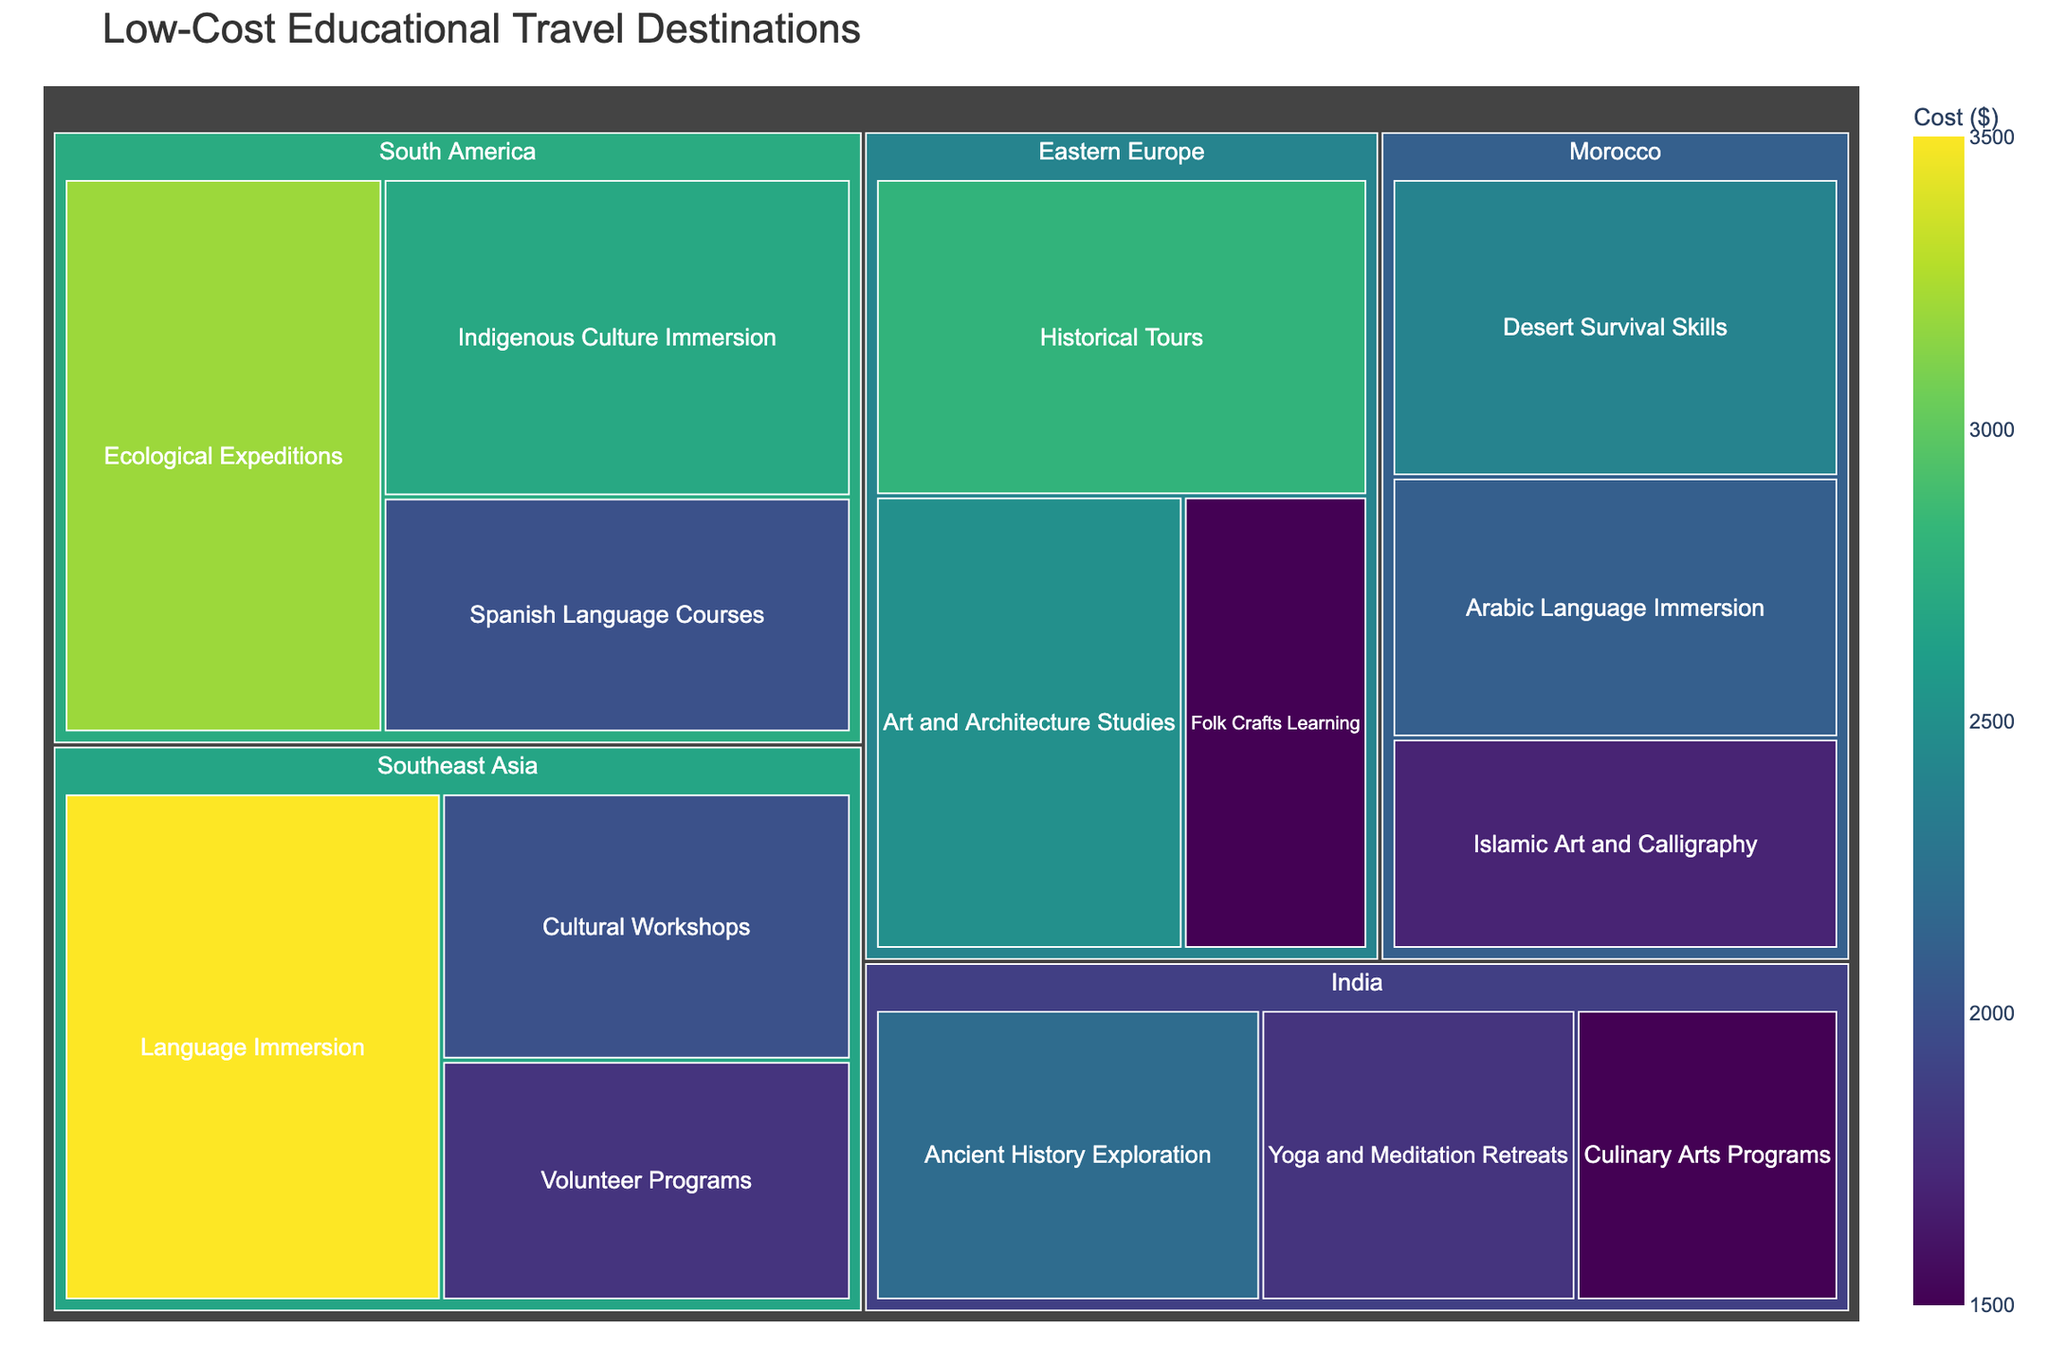What's the title of the treemap? The title is usually displayed at the top of the treemap. It is meant to summarize the overall content of the visualization.
Answer: Low-Cost Educational Travel Destinations How many regions are represented in the treemap? By examining the top-level categories in the treemap, you can count the distinct regions.
Answer: 5 What is the cost of attending Yoga and Meditation Retreats in India? Locate the "India" region and then find the "Yoga and Meditation Retreats" category within it. The cost is displayed within that segment.
Answer: $1800 Which region has the least expensive learning opportunity, and what is the opportunity? Identify the smallest rectangle with the lowest cost value displayed. Cross-check which region it belongs to.
Answer: Eastern Europe, Folk Crafts Learning Compare the costs of Language Immersion programs in Southeast Asia and Arabic Language Immersion in Morocco. Which one is cheaper? Locate both categories in their respective regions and compare their cost values directly.
Answer: Arabic Language Immersion in Morocco What is the total cost of all learning opportunities in South America? Sum the costs of all the segments within the South America region. Individual costs are $3200, $2700, and $2000 respectively. So, 3200 + 2700 + 2000 = 7900.
Answer: $7900 Which learning opportunity has the highest cost, and how much does it cost? Find the segment with the highest value. Look across all regions to identify this.
Answer: Language Immersion in Southeast Asia, $3500 How many different types of learning opportunities are offered in Eastern Europe? Count the number of distinct segments within the Eastern Europe region.
Answer: 3 What's the cost difference between Ecological Expeditions in South America and Desert Survival Skills in Morocco? Find the cost of each learning opportunity and subtract the lower cost from the higher cost. $3200 - $2400 = $800
Answer: $800 In which region is the 'Art and Architecture Studies' learning opportunity offered, and what is its cost? Identify the segment labeled "Art and Architecture Studies" and see which region it falls under.
Answer: Eastern Europe, $2500 